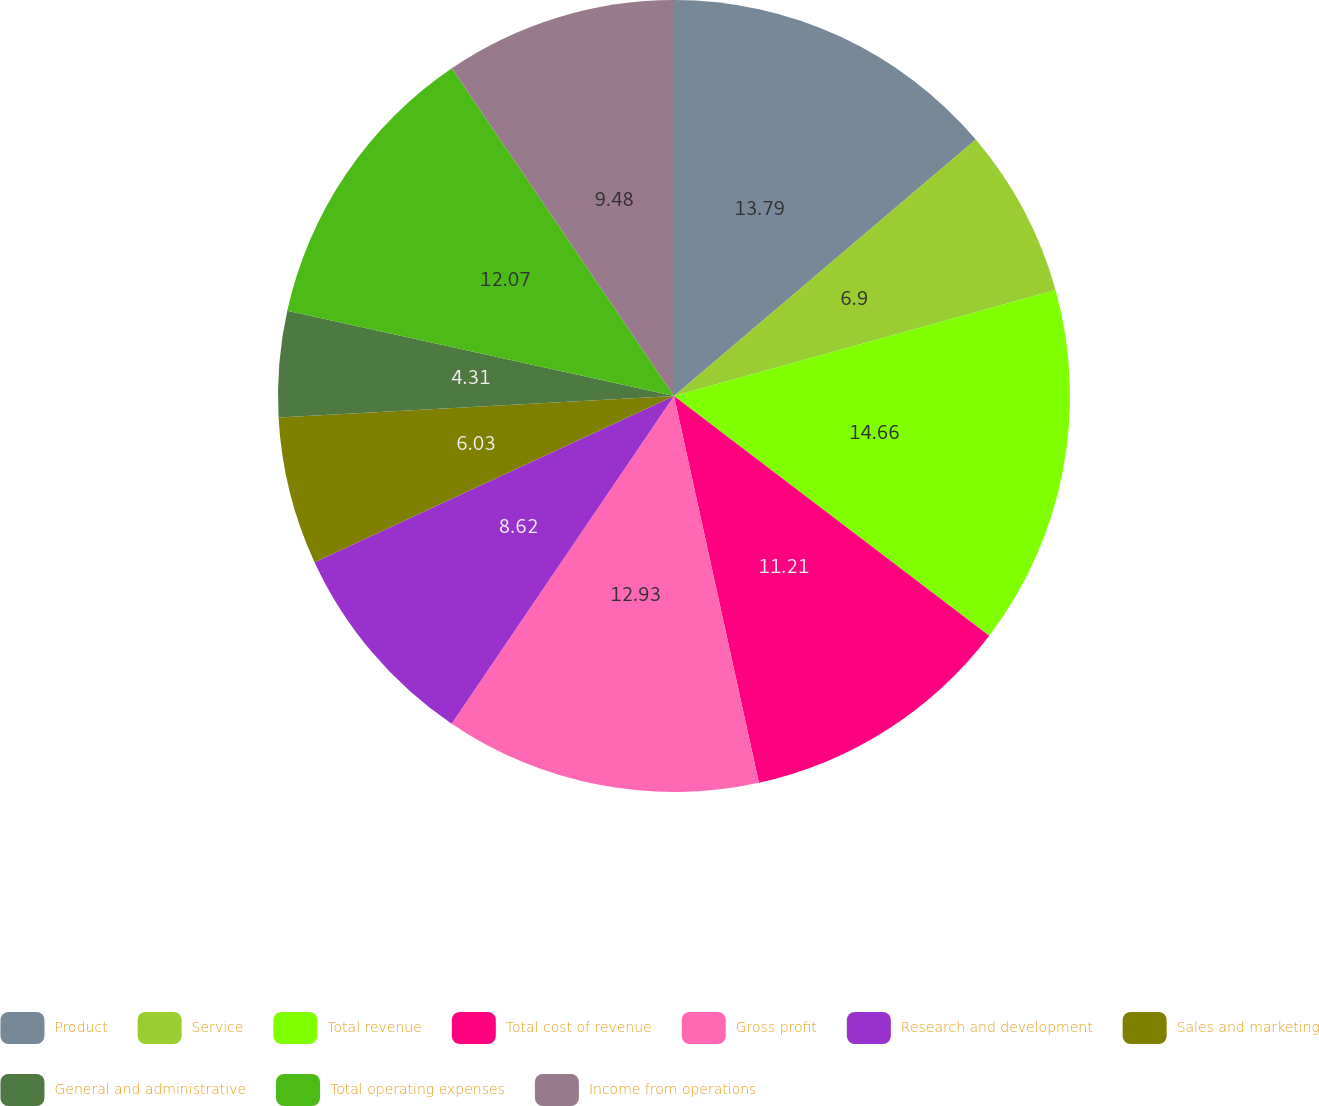<chart> <loc_0><loc_0><loc_500><loc_500><pie_chart><fcel>Product<fcel>Service<fcel>Total revenue<fcel>Total cost of revenue<fcel>Gross profit<fcel>Research and development<fcel>Sales and marketing<fcel>General and administrative<fcel>Total operating expenses<fcel>Income from operations<nl><fcel>13.79%<fcel>6.9%<fcel>14.66%<fcel>11.21%<fcel>12.93%<fcel>8.62%<fcel>6.03%<fcel>4.31%<fcel>12.07%<fcel>9.48%<nl></chart> 